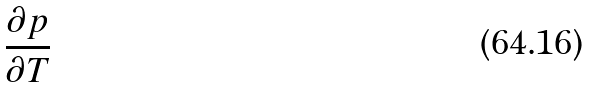<formula> <loc_0><loc_0><loc_500><loc_500>\frac { \partial p } { \partial T }</formula> 